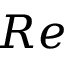Convert formula to latex. <formula><loc_0><loc_0><loc_500><loc_500>R e</formula> 